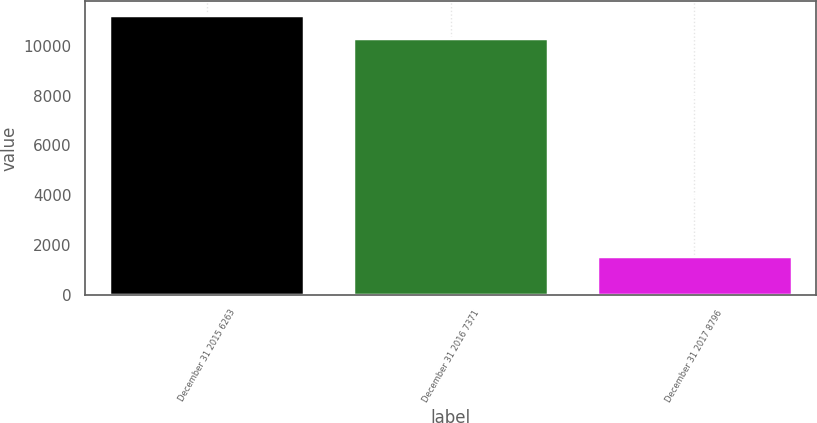<chart> <loc_0><loc_0><loc_500><loc_500><bar_chart><fcel>December 31 2015 6263<fcel>December 31 2016 7371<fcel>December 31 2017 8796<nl><fcel>11218.4<fcel>10303<fcel>1556<nl></chart> 